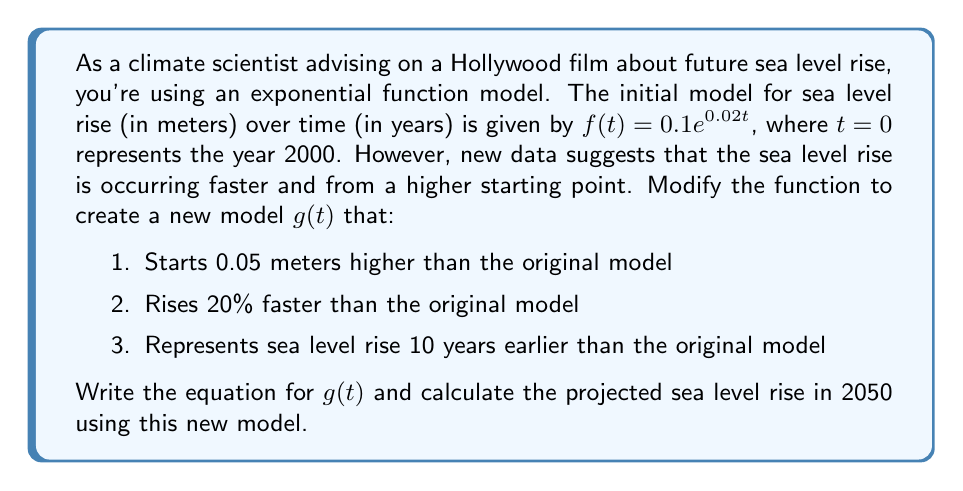Could you help me with this problem? Let's approach this step-by-step:

1) To start 0.05 meters higher, we need to apply a vertical shift of +0.05 to the original function:
   $f_1(t) = 0.1e^{0.02t} + 0.05$

2) To make it rise 20% faster, we need to multiply the exponent by 1.2:
   $f_2(t) = 0.1e^{0.02 \cdot 1.2t} + 0.05 = 0.1e^{0.024t} + 0.05$

3) To represent the sea level rise 10 years earlier, we need to apply a horizontal shift of +10:
   $g(t) = 0.1e^{0.024(t+10)} + 0.05$

Now we have our final function $g(t)$. Let's simplify it:

$g(t) = 0.1e^{0.024(t+10)} + 0.05$
$g(t) = 0.1e^{0.024t} \cdot e^{0.24} + 0.05$
$g(t) = 0.1 \cdot 1.271 \cdot e^{0.024t} + 0.05$
$g(t) = 0.1271e^{0.024t} + 0.05$

To calculate the projected sea level rise in 2050:
2050 is 50 years after 2000, so we need to calculate $g(50)$:

$g(50) = 0.1271e^{0.024 \cdot 50} + 0.05$
$g(50) = 0.1271e^{1.2} + 0.05$
$g(50) = 0.1271 \cdot 3.3201 + 0.05$
$g(50) = 0.4220 + 0.05 = 0.4720$

Therefore, the projected sea level rise in 2050 according to this model is approximately 0.4720 meters.
Answer: $g(t) = 0.1271e^{0.024t} + 0.05$

Projected sea level rise in 2050: 0.4720 meters 